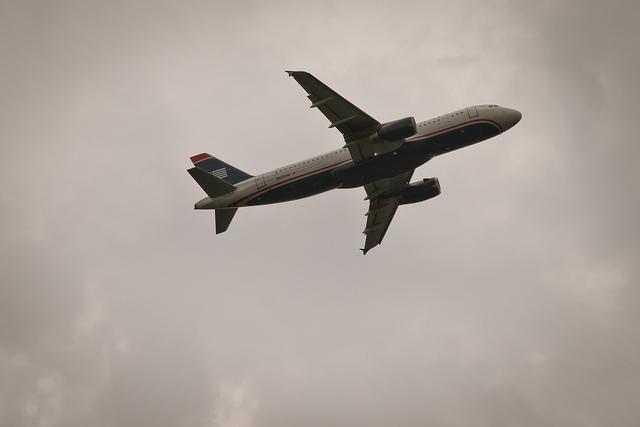How many of the men are wearing hats?
Give a very brief answer. 0. 